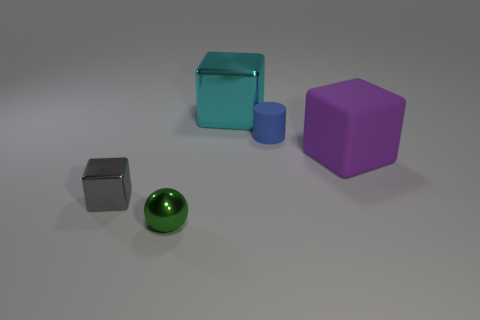What is the size of the gray object that is made of the same material as the green sphere?
Make the answer very short. Small. There is a gray metallic block; is it the same size as the block on the right side of the large cyan object?
Your answer should be very brief. No. What shape is the tiny object that is in front of the tiny block?
Make the answer very short. Sphere. There is a small blue matte object that is to the right of the metal object to the left of the green metallic sphere; is there a big purple object that is behind it?
Your response must be concise. No. What is the material of the purple object that is the same shape as the tiny gray thing?
Keep it short and to the point. Rubber. Are there any other things that are made of the same material as the cyan object?
Give a very brief answer. Yes. What number of cubes are either small purple objects or small gray things?
Keep it short and to the point. 1. Do the block that is behind the purple rubber block and the shiny object to the left of the tiny green metal object have the same size?
Offer a very short reply. No. There is a block in front of the big block on the right side of the big shiny object; what is it made of?
Make the answer very short. Metal. Are there fewer big blocks that are in front of the large cyan cube than small green metallic things?
Ensure brevity in your answer.  No. 